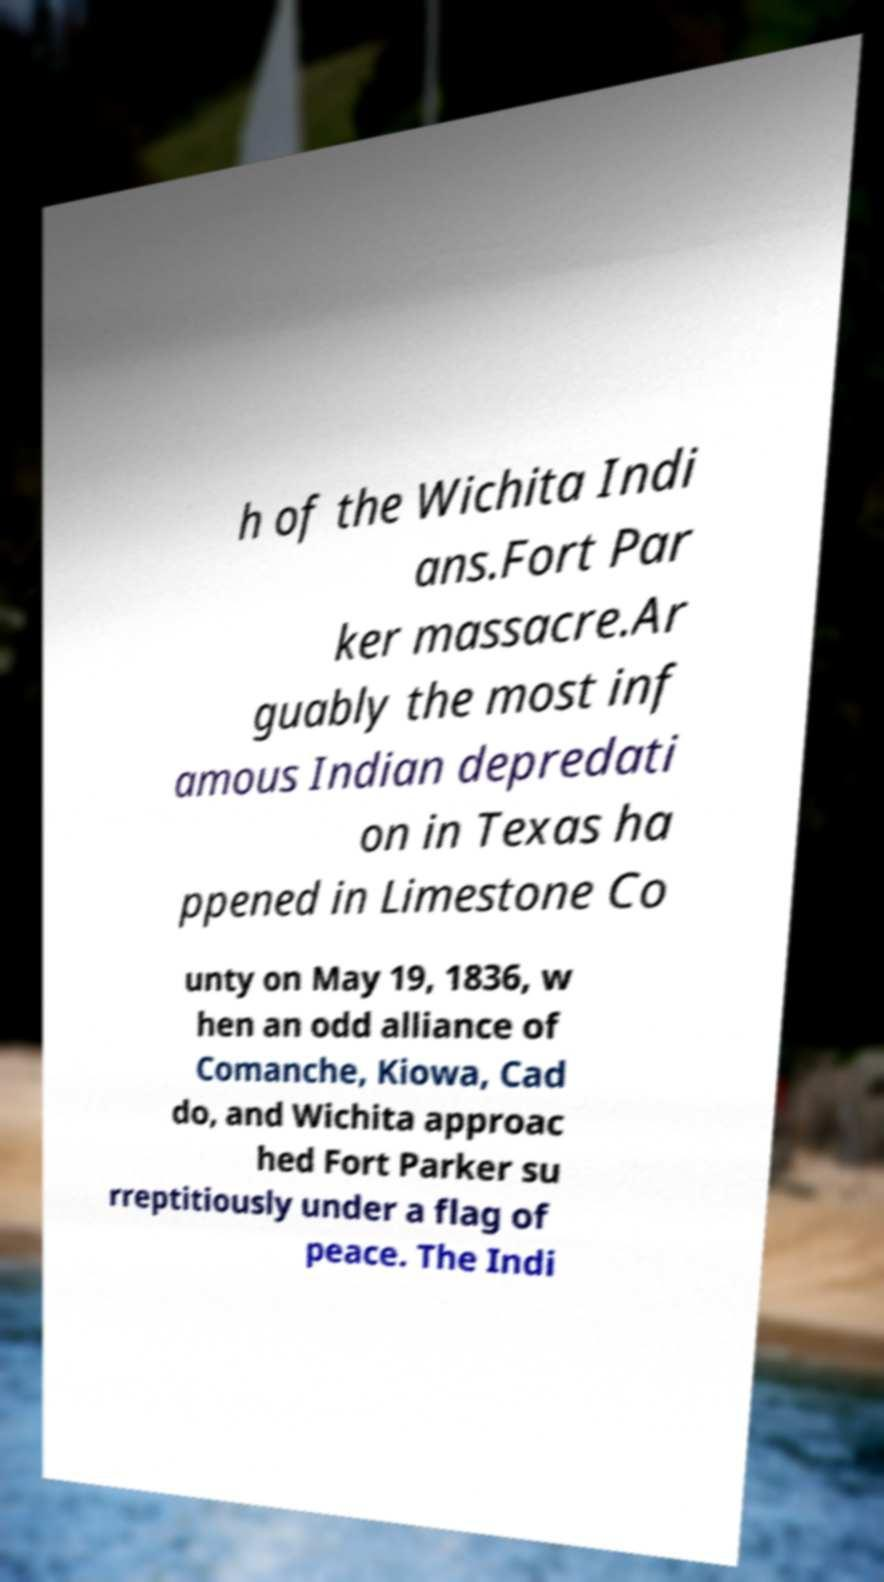I need the written content from this picture converted into text. Can you do that? h of the Wichita Indi ans.Fort Par ker massacre.Ar guably the most inf amous Indian depredati on in Texas ha ppened in Limestone Co unty on May 19, 1836, w hen an odd alliance of Comanche, Kiowa, Cad do, and Wichita approac hed Fort Parker su rreptitiously under a flag of peace. The Indi 